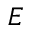Convert formula to latex. <formula><loc_0><loc_0><loc_500><loc_500>E</formula> 